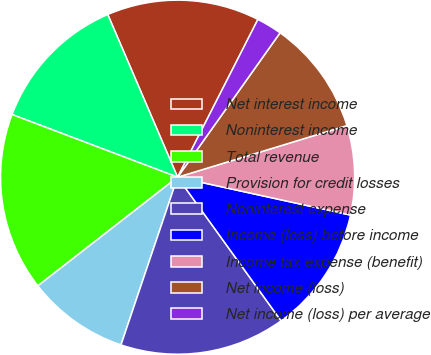<chart> <loc_0><loc_0><loc_500><loc_500><pie_chart><fcel>Net interest income<fcel>Noninterest income<fcel>Total revenue<fcel>Provision for credit losses<fcel>Noninterest expense<fcel>Income (loss) before income<fcel>Income tax expense (benefit)<fcel>Net income (loss)<fcel>Net income (loss) per average<nl><fcel>13.95%<fcel>12.79%<fcel>16.28%<fcel>9.3%<fcel>15.12%<fcel>11.63%<fcel>8.14%<fcel>10.47%<fcel>2.33%<nl></chart> 